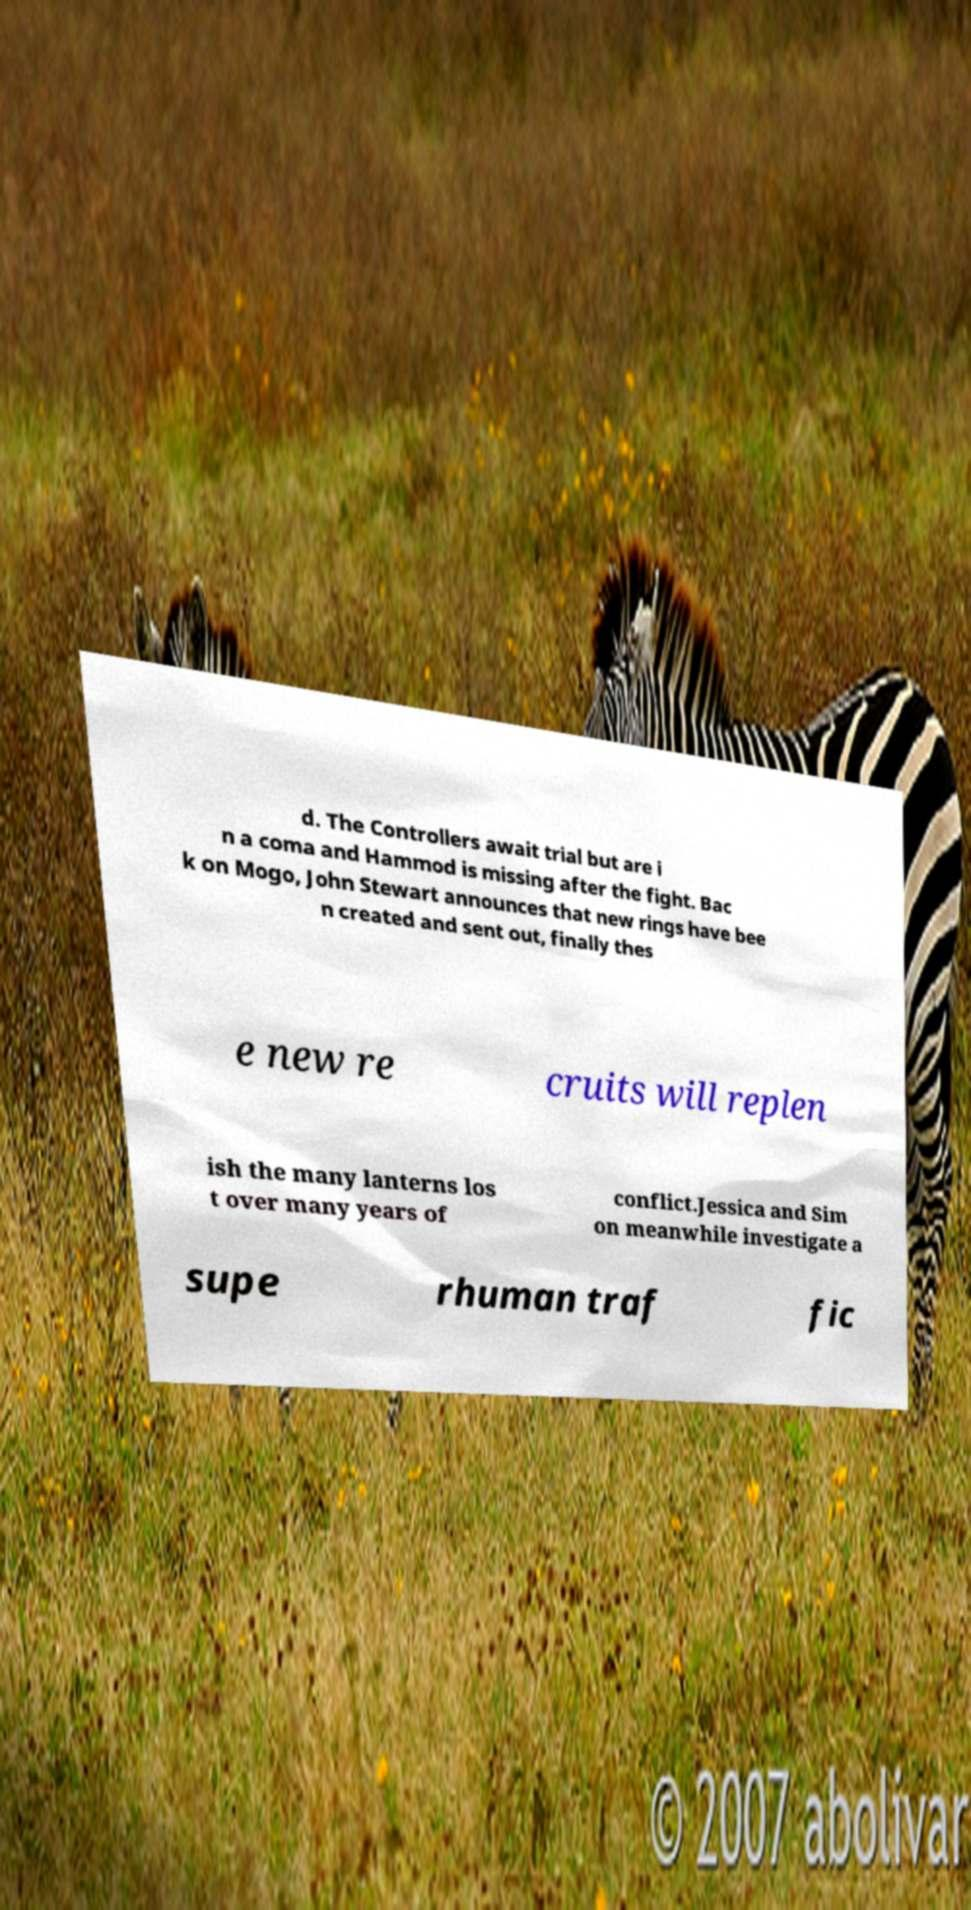Can you read and provide the text displayed in the image?This photo seems to have some interesting text. Can you extract and type it out for me? d. The Controllers await trial but are i n a coma and Hammod is missing after the fight. Bac k on Mogo, John Stewart announces that new rings have bee n created and sent out, finally thes e new re cruits will replen ish the many lanterns los t over many years of conflict.Jessica and Sim on meanwhile investigate a supe rhuman traf fic 